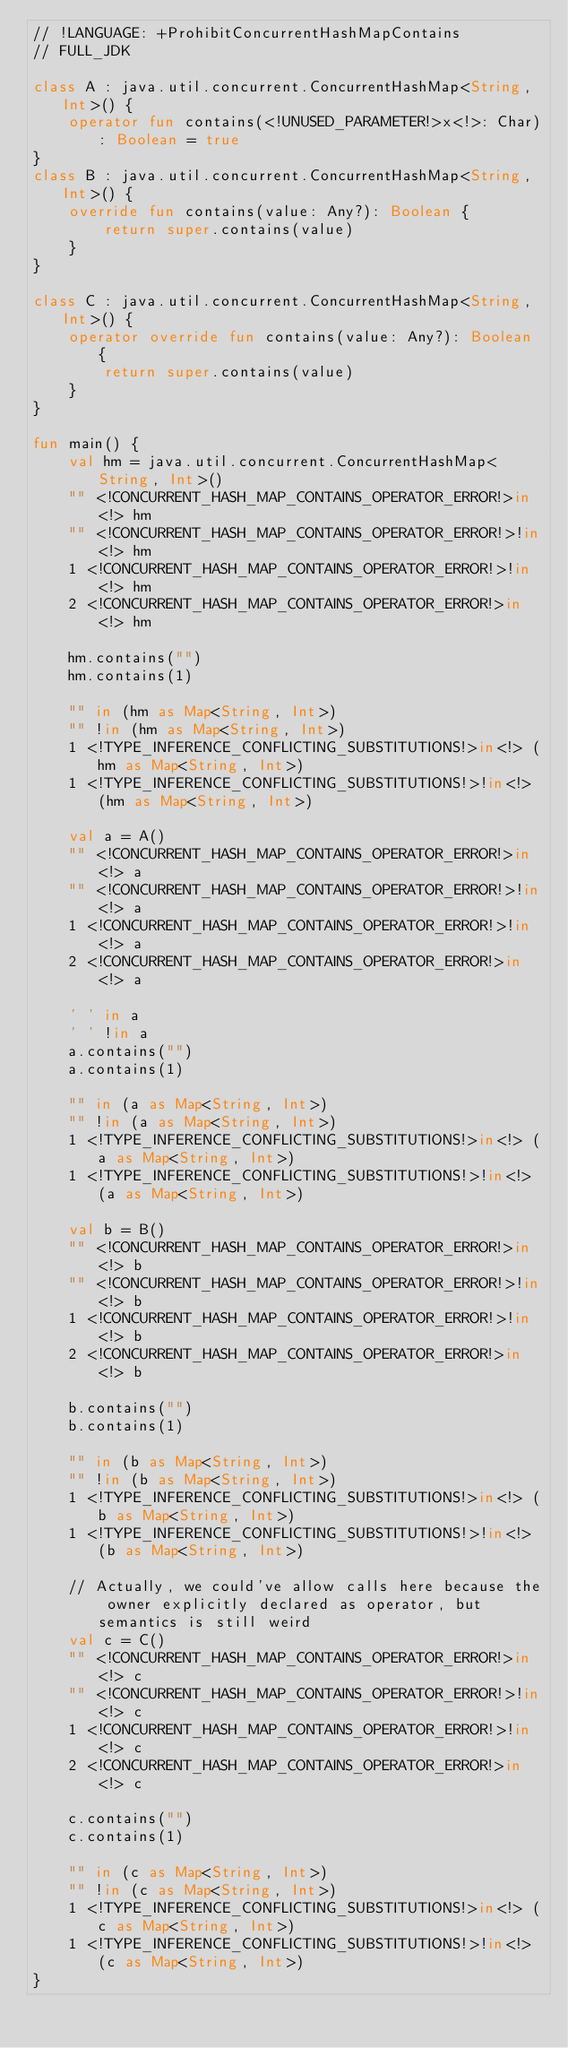Convert code to text. <code><loc_0><loc_0><loc_500><loc_500><_Kotlin_>// !LANGUAGE: +ProhibitConcurrentHashMapContains
// FULL_JDK

class A : java.util.concurrent.ConcurrentHashMap<String, Int>() {
    operator fun contains(<!UNUSED_PARAMETER!>x<!>: Char): Boolean = true
}
class B : java.util.concurrent.ConcurrentHashMap<String, Int>() {
    override fun contains(value: Any?): Boolean {
        return super.contains(value)
    }
}

class C : java.util.concurrent.ConcurrentHashMap<String, Int>() {
    operator override fun contains(value: Any?): Boolean {
        return super.contains(value)
    }
}

fun main() {
    val hm = java.util.concurrent.ConcurrentHashMap<String, Int>()
    "" <!CONCURRENT_HASH_MAP_CONTAINS_OPERATOR_ERROR!>in<!> hm
    "" <!CONCURRENT_HASH_MAP_CONTAINS_OPERATOR_ERROR!>!in<!> hm
    1 <!CONCURRENT_HASH_MAP_CONTAINS_OPERATOR_ERROR!>!in<!> hm
    2 <!CONCURRENT_HASH_MAP_CONTAINS_OPERATOR_ERROR!>in<!> hm

    hm.contains("")
    hm.contains(1)

    "" in (hm as Map<String, Int>)
    "" !in (hm as Map<String, Int>)
    1 <!TYPE_INFERENCE_CONFLICTING_SUBSTITUTIONS!>in<!> (hm as Map<String, Int>)
    1 <!TYPE_INFERENCE_CONFLICTING_SUBSTITUTIONS!>!in<!> (hm as Map<String, Int>)

    val a = A()
    "" <!CONCURRENT_HASH_MAP_CONTAINS_OPERATOR_ERROR!>in<!> a
    "" <!CONCURRENT_HASH_MAP_CONTAINS_OPERATOR_ERROR!>!in<!> a
    1 <!CONCURRENT_HASH_MAP_CONTAINS_OPERATOR_ERROR!>!in<!> a
    2 <!CONCURRENT_HASH_MAP_CONTAINS_OPERATOR_ERROR!>in<!> a

    ' ' in a
    ' ' !in a
    a.contains("")
    a.contains(1)

    "" in (a as Map<String, Int>)
    "" !in (a as Map<String, Int>)
    1 <!TYPE_INFERENCE_CONFLICTING_SUBSTITUTIONS!>in<!> (a as Map<String, Int>)
    1 <!TYPE_INFERENCE_CONFLICTING_SUBSTITUTIONS!>!in<!> (a as Map<String, Int>)

    val b = B()
    "" <!CONCURRENT_HASH_MAP_CONTAINS_OPERATOR_ERROR!>in<!> b
    "" <!CONCURRENT_HASH_MAP_CONTAINS_OPERATOR_ERROR!>!in<!> b
    1 <!CONCURRENT_HASH_MAP_CONTAINS_OPERATOR_ERROR!>!in<!> b
    2 <!CONCURRENT_HASH_MAP_CONTAINS_OPERATOR_ERROR!>in<!> b

    b.contains("")
    b.contains(1)

    "" in (b as Map<String, Int>)
    "" !in (b as Map<String, Int>)
    1 <!TYPE_INFERENCE_CONFLICTING_SUBSTITUTIONS!>in<!> (b as Map<String, Int>)
    1 <!TYPE_INFERENCE_CONFLICTING_SUBSTITUTIONS!>!in<!> (b as Map<String, Int>)

    // Actually, we could've allow calls here because the owner explicitly declared as operator, but semantics is still weird
    val c = C()
    "" <!CONCURRENT_HASH_MAP_CONTAINS_OPERATOR_ERROR!>in<!> c
    "" <!CONCURRENT_HASH_MAP_CONTAINS_OPERATOR_ERROR!>!in<!> c
    1 <!CONCURRENT_HASH_MAP_CONTAINS_OPERATOR_ERROR!>!in<!> c
    2 <!CONCURRENT_HASH_MAP_CONTAINS_OPERATOR_ERROR!>in<!> c

    c.contains("")
    c.contains(1)

    "" in (c as Map<String, Int>)
    "" !in (c as Map<String, Int>)
    1 <!TYPE_INFERENCE_CONFLICTING_SUBSTITUTIONS!>in<!> (c as Map<String, Int>)
    1 <!TYPE_INFERENCE_CONFLICTING_SUBSTITUTIONS!>!in<!> (c as Map<String, Int>)
}

</code> 